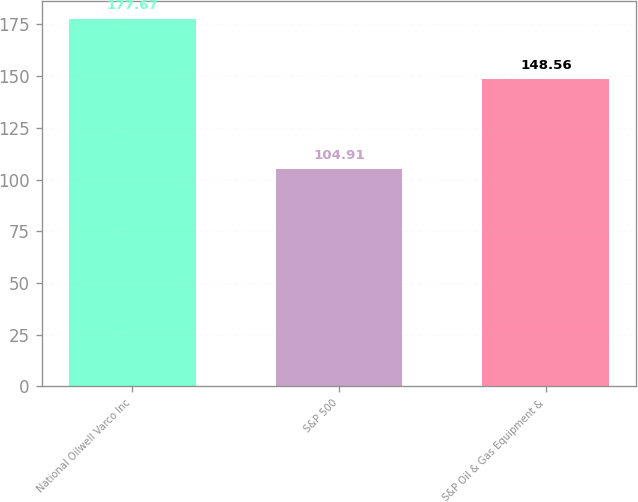Convert chart to OTSL. <chart><loc_0><loc_0><loc_500><loc_500><bar_chart><fcel>National Oilwell Varco Inc<fcel>S&P 500<fcel>S&P Oil & Gas Equipment &<nl><fcel>177.67<fcel>104.91<fcel>148.56<nl></chart> 